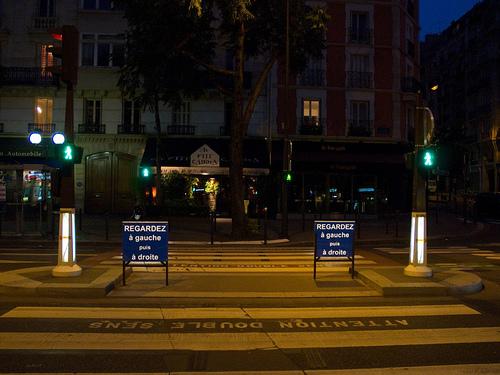What color are the two signs in the entrance of the building?
Quick response, please. Blue. What is written on the step?
Answer briefly. Attention double sens. What is the company in the background?
Short answer required. Restaurant. 